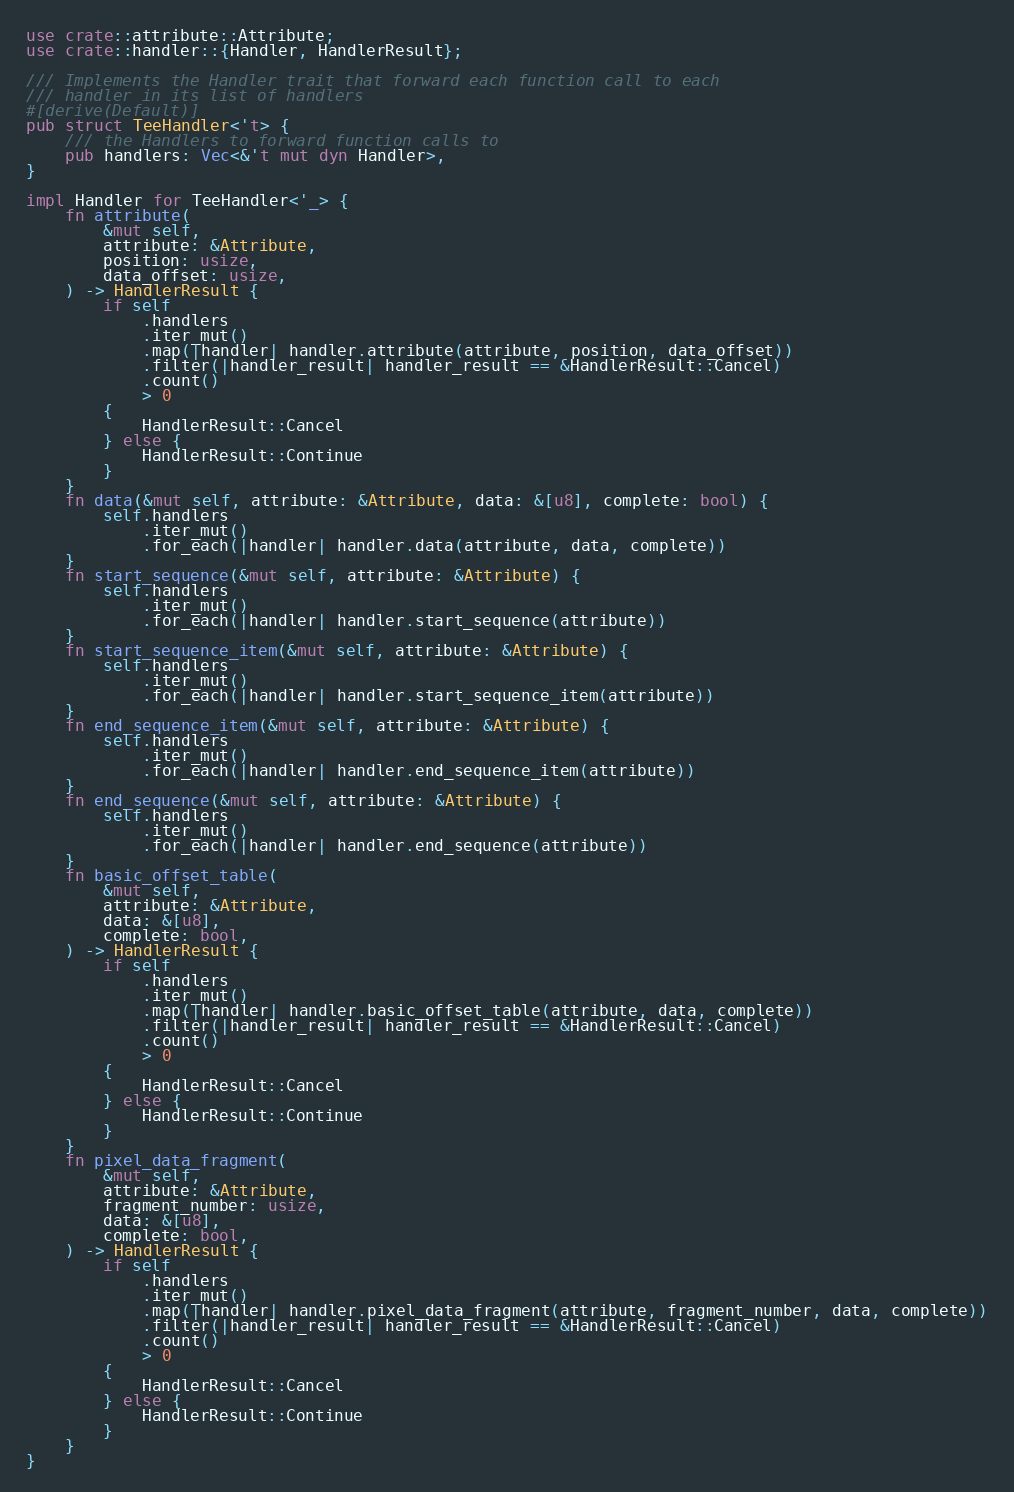Convert code to text. <code><loc_0><loc_0><loc_500><loc_500><_Rust_>use crate::attribute::Attribute;
use crate::handler::{Handler, HandlerResult};

/// Implements the Handler trait that forward each function call to each
/// handler in its list of handlers
#[derive(Default)]
pub struct TeeHandler<'t> {
    /// the Handlers to forward function calls to
    pub handlers: Vec<&'t mut dyn Handler>,
}

impl Handler for TeeHandler<'_> {
    fn attribute(
        &mut self,
        attribute: &Attribute,
        position: usize,
        data_offset: usize,
    ) -> HandlerResult {
        if self
            .handlers
            .iter_mut()
            .map(|handler| handler.attribute(attribute, position, data_offset))
            .filter(|handler_result| handler_result == &HandlerResult::Cancel)
            .count()
            > 0
        {
            HandlerResult::Cancel
        } else {
            HandlerResult::Continue
        }
    }
    fn data(&mut self, attribute: &Attribute, data: &[u8], complete: bool) {
        self.handlers
            .iter_mut()
            .for_each(|handler| handler.data(attribute, data, complete))
    }
    fn start_sequence(&mut self, attribute: &Attribute) {
        self.handlers
            .iter_mut()
            .for_each(|handler| handler.start_sequence(attribute))
    }
    fn start_sequence_item(&mut self, attribute: &Attribute) {
        self.handlers
            .iter_mut()
            .for_each(|handler| handler.start_sequence_item(attribute))
    }
    fn end_sequence_item(&mut self, attribute: &Attribute) {
        self.handlers
            .iter_mut()
            .for_each(|handler| handler.end_sequence_item(attribute))
    }
    fn end_sequence(&mut self, attribute: &Attribute) {
        self.handlers
            .iter_mut()
            .for_each(|handler| handler.end_sequence(attribute))
    }
    fn basic_offset_table(
        &mut self,
        attribute: &Attribute,
        data: &[u8],
        complete: bool,
    ) -> HandlerResult {
        if self
            .handlers
            .iter_mut()
            .map(|handler| handler.basic_offset_table(attribute, data, complete))
            .filter(|handler_result| handler_result == &HandlerResult::Cancel)
            .count()
            > 0
        {
            HandlerResult::Cancel
        } else {
            HandlerResult::Continue
        }
    }
    fn pixel_data_fragment(
        &mut self,
        attribute: &Attribute,
        fragment_number: usize,
        data: &[u8],
        complete: bool,
    ) -> HandlerResult {
        if self
            .handlers
            .iter_mut()
            .map(|handler| handler.pixel_data_fragment(attribute, fragment_number, data, complete))
            .filter(|handler_result| handler_result == &HandlerResult::Cancel)
            .count()
            > 0
        {
            HandlerResult::Cancel
        } else {
            HandlerResult::Continue
        }
    }
}
</code> 